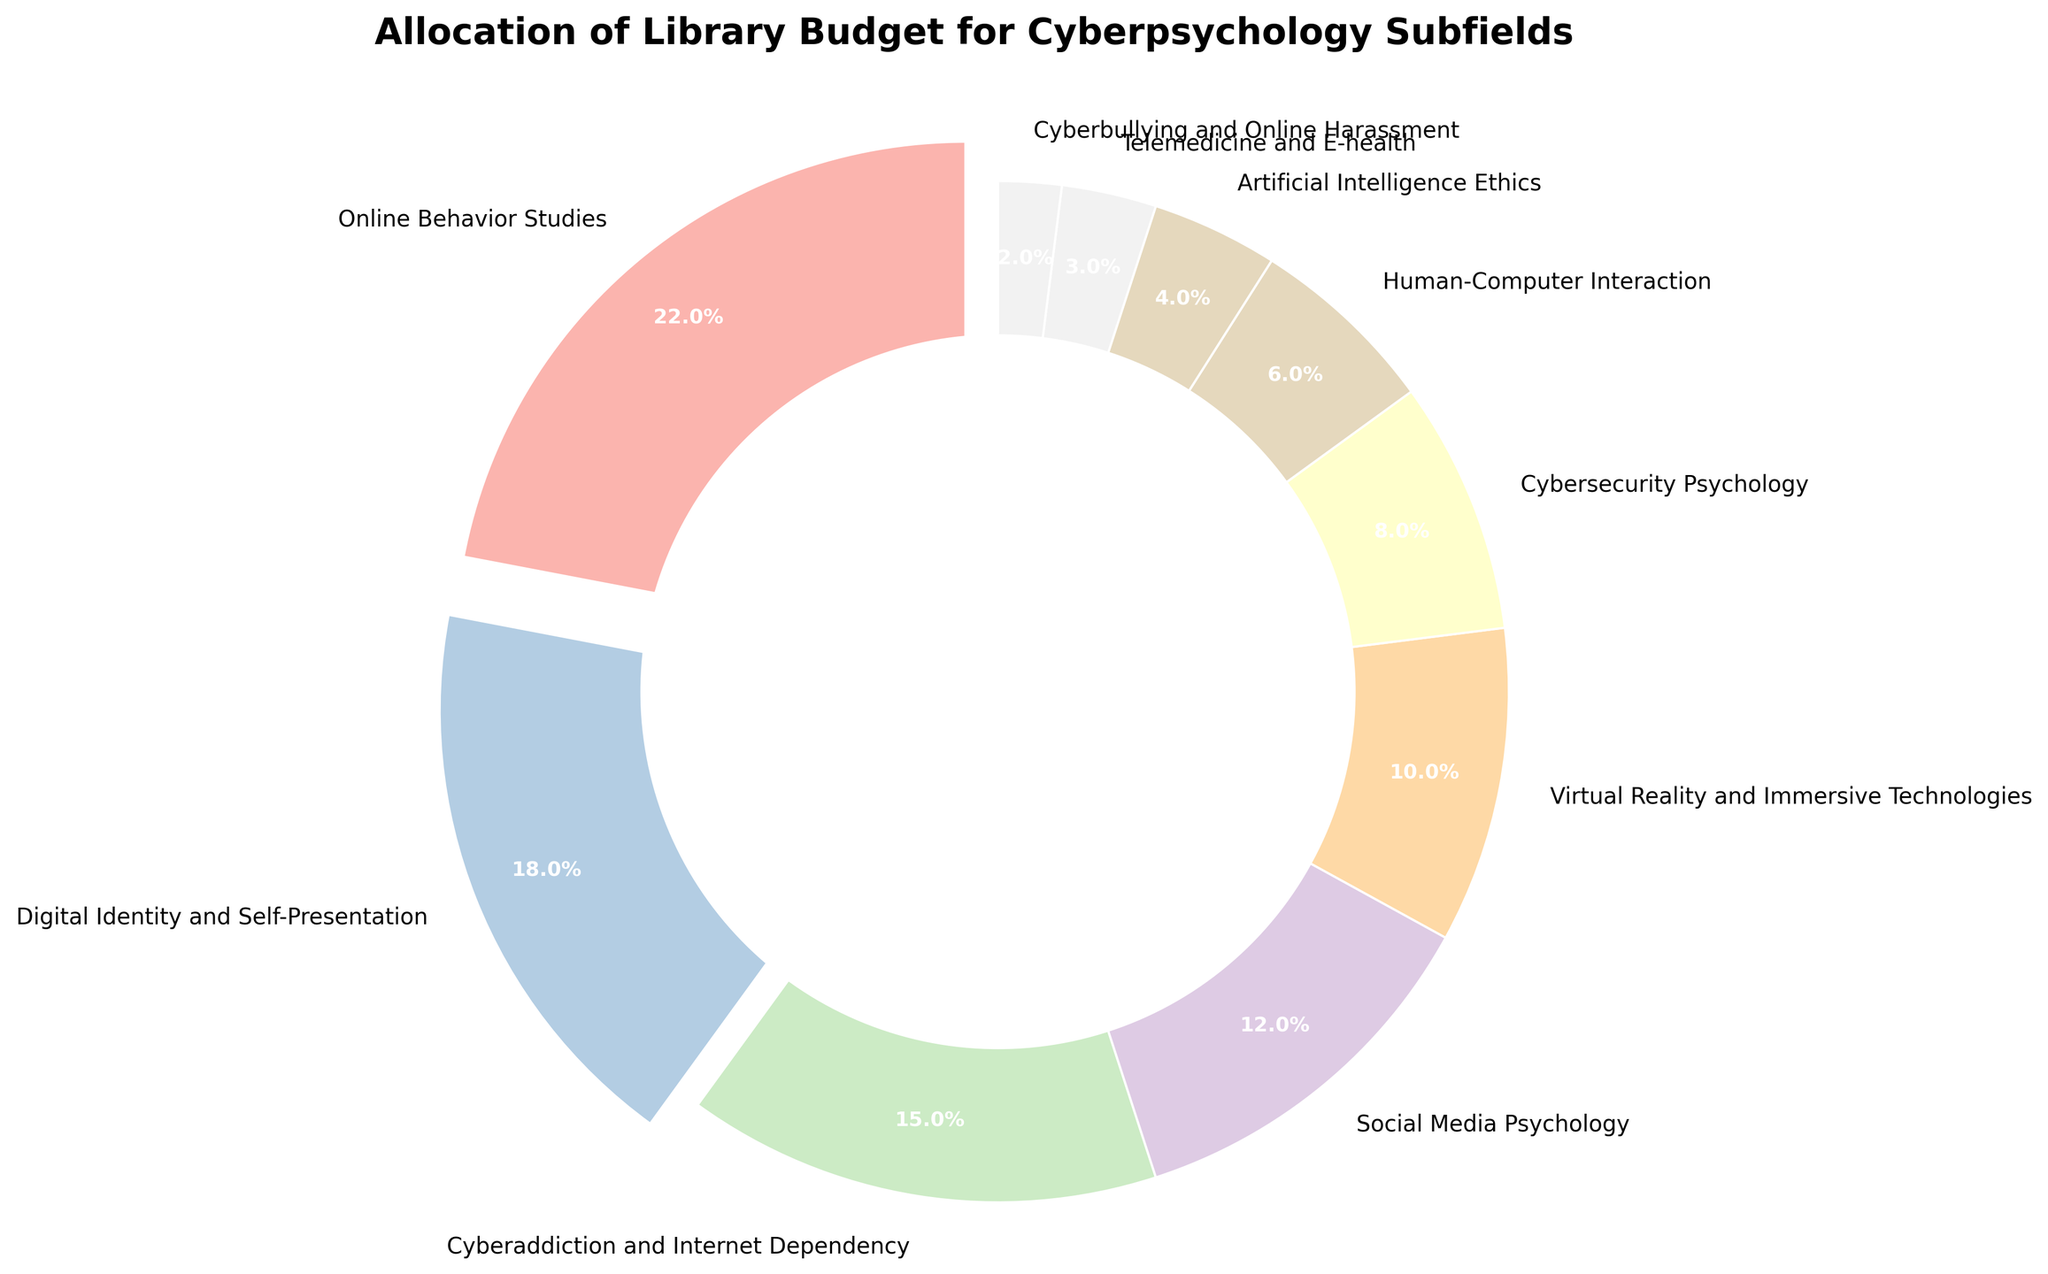What is the largest allocation of the library budget and which category does it belong to? Look at the percentage values shown on the pie chart. The largest value is 22%, which belongs to the category "Online Behavior Studies".
Answer: Online Behavior Studies, 22% What is the total percentage of the budget allocated to categories with more than 15%? Identify categories above 15%: "Online Behavior Studies" (22%) and "Digital Identity and Self-Presentation" (18%). Sum these values: 22% + 18% = 40%.
Answer: 40% Which category has the smallest allocation and what is the percentage? Look at the pie chart to find the smallest segment. "Cyberbullying and Online Harassment" is the smallest with 2%.
Answer: Cyberbullying and Online Harassment, 2% How much more is allocated to "Social Media Psychology" compared to "Cybersecurity Psychology"? Locate these categories in the pie chart. "Social Media Psychology" has 12% and "Cybersecurity Psychology" has 8%. Subtract the smaller from the larger: 12% - 8% = 4%.
Answer: 4% What is the combined allocation for "Artificial Intelligence Ethics" and "Telemedicine and E-health"? Sum their percentages from the pie chart: 4% (Artificial Intelligence Ethics) + 3% (Telemedicine and E-health) = 7%.
Answer: 7% Which categories have their budget allocation visualized with an exploded segment? Observe the pie chart. Segments are exploded for categories with more than 15%: "Online Behavior Studies" (22%) and "Digital Identity and Self-Presentation" (18%).
Answer: Online Behavior Studies and Digital Identity and Self-Presentation Rank the categories in descending order of their budget allocation. From the pie chart: Online Behavior Studies (22%), Digital Identity and Self-Presentation (18%), Cyberaddiction and Internet Dependency (15%), Social Media Psychology (12%), Virtual Reality and Immersive Technologies (10%), Cybersecurity Psychology (8%), Human-Computer Interaction (6%), Artificial Intelligence Ethics (4%), Telemedicine and E-health (3%), Cyberbullying and Online Harassment (2%).
Answer: Online Behavior Studies, Digital Identity and Self-Presentation, Cyberaddiction and Internet Dependency, Social Media Psychology, Virtual Reality and Immersive Technologies, Cybersecurity Psychology, Human-Computer Interaction, Artificial Intelligence Ethics, Telemedicine and E-health, Cyberbullying and Online Harassment What is the percentage difference between the highest and lowest budget allocations? Identify the highest (22%) and lowest (2%) values from the pie chart. Subtract the smaller from the larger: 22% - 2% = 20%.
Answer: 20% 